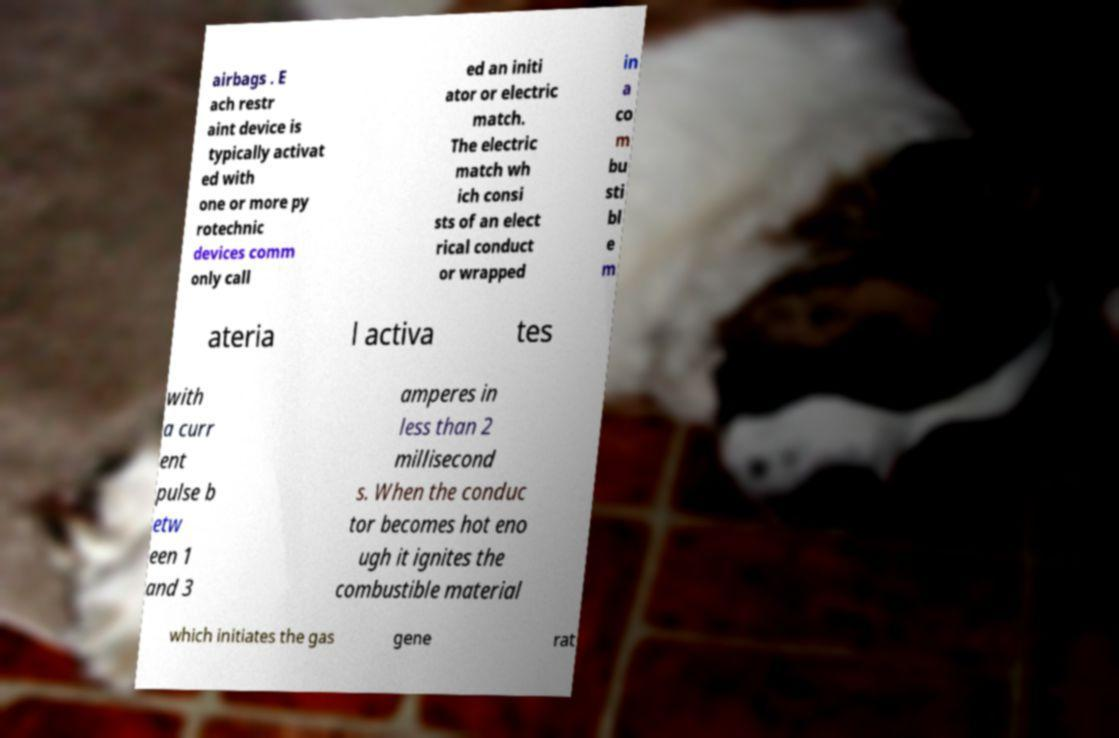Can you read and provide the text displayed in the image?This photo seems to have some interesting text. Can you extract and type it out for me? airbags . E ach restr aint device is typically activat ed with one or more py rotechnic devices comm only call ed an initi ator or electric match. The electric match wh ich consi sts of an elect rical conduct or wrapped in a co m bu sti bl e m ateria l activa tes with a curr ent pulse b etw een 1 and 3 amperes in less than 2 millisecond s. When the conduc tor becomes hot eno ugh it ignites the combustible material which initiates the gas gene rat 